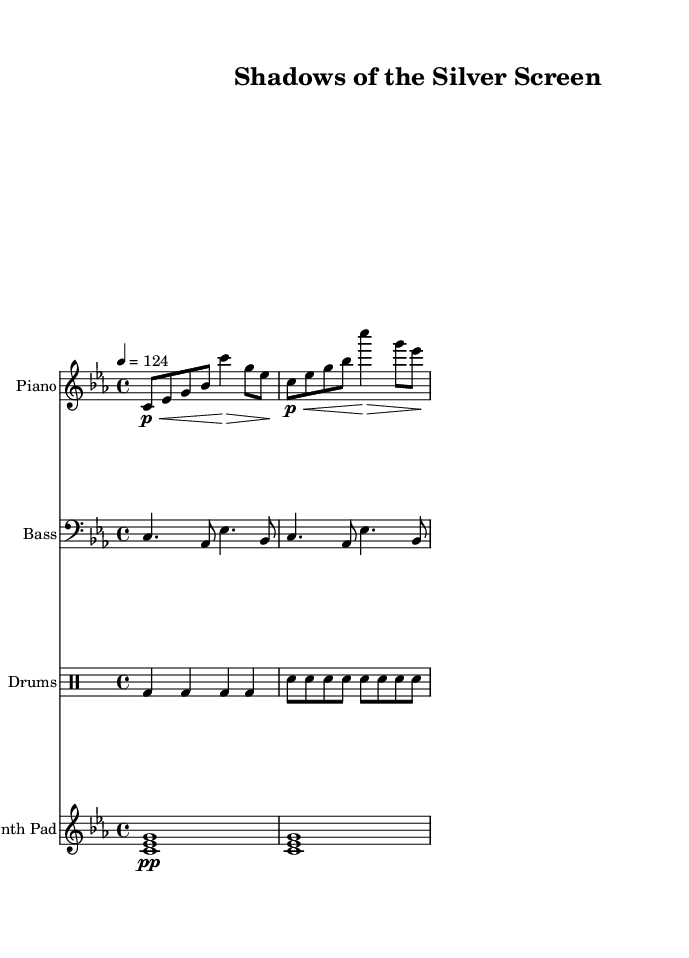What is the key signature of this music? The key signature is indicated by the sharps or flats at the beginning of the staff. In this piece, there are no sharps or flats, which signifies it is in C minor.
Answer: C minor What is the time signature of this music? The time signature is indicated by the two numbers at the beginning of the piece, where the top number (4) represents the number of beats in a measure and the bottom number (4) indicates that the quarter note gets one beat. Here, it is 4/4.
Answer: 4/4 What is the tempo marking of this music? The tempo marking is indicated by the number after “tempo”. In this case, it says "4 = 124”, meaning a quarter note should be played at 124 beats per minute.
Answer: 124 How many measures are in the piano part? By counting the bar lines in the piano section, we can see that there are a total of four measures present in the excerpt.
Answer: 4 Which instrument plays the synth pad? The synth pad is indicated by the staff labeled "Synth Pad", clarifying which instrument is designated for that part.
Answer: Synth Pad Does the bass part include any rests? Looking closely at the bass part, we can observe that there are no rests present; it consists of all played notes throughout the provided measures.
Answer: No What style influences the melodies in this music? The combination of deep house elements with noir-inspired melodies suggests an influence from the atmospheric and emotive soundtracks characteristic of 1920s cinema.
Answer: Noir-inspired 